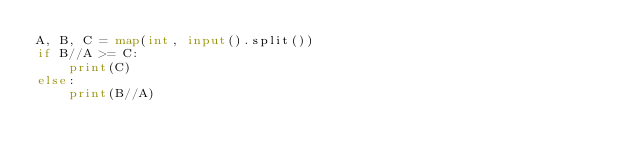Convert code to text. <code><loc_0><loc_0><loc_500><loc_500><_Python_>A, B, C = map(int, input().split())
if B//A >= C:
    print(C)
else:
    print(B//A)</code> 